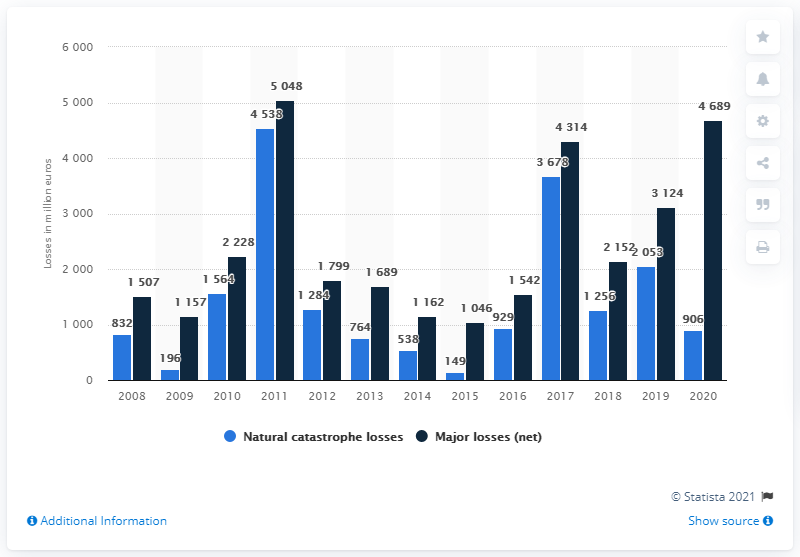Draw attention to some important aspects in this diagram. The reinsurance losses of Munich Re due to natural disasters in 2020 were approximately $906 million. 